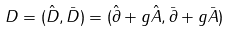Convert formula to latex. <formula><loc_0><loc_0><loc_500><loc_500>D = ( \hat { D } , \bar { D } ) = ( \hat { \partial } + g \hat { A } , \bar { \partial } + g \bar { A } )</formula> 